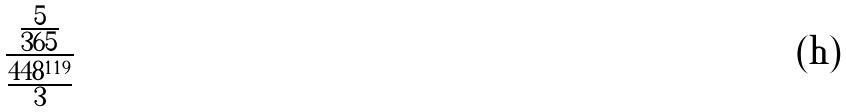<formula> <loc_0><loc_0><loc_500><loc_500>\frac { \frac { 5 } { 3 6 5 } } { \frac { 4 4 8 ^ { 1 1 9 } } { 3 } }</formula> 